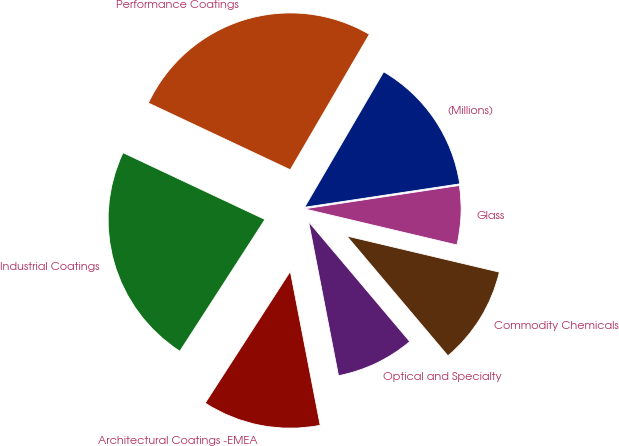Convert chart. <chart><loc_0><loc_0><loc_500><loc_500><pie_chart><fcel>(Millions)<fcel>Performance Coatings<fcel>Industrial Coatings<fcel>Architectural Coatings -EMEA<fcel>Optical and Specialty<fcel>Commodity Chemicals<fcel>Glass<nl><fcel>14.21%<fcel>26.41%<fcel>22.87%<fcel>12.18%<fcel>8.11%<fcel>10.14%<fcel>6.08%<nl></chart> 